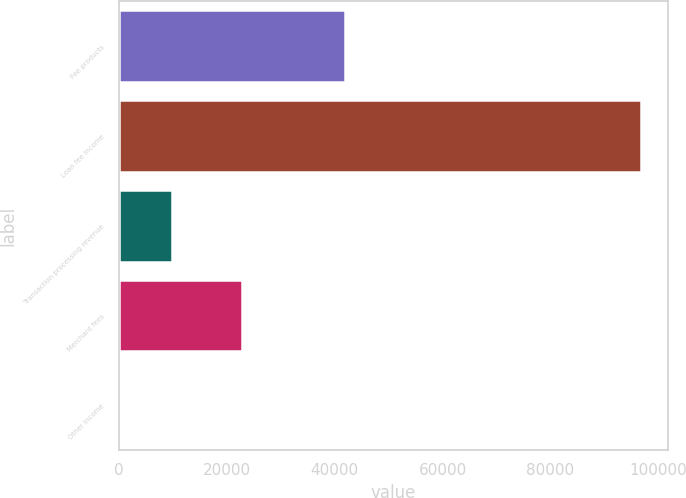Convert chart. <chart><loc_0><loc_0><loc_500><loc_500><bar_chart><fcel>Fee products<fcel>Loan fee income<fcel>Transaction processing revenue<fcel>Merchant fees<fcel>Other income<nl><fcel>41829<fcel>96874<fcel>9848.5<fcel>22779<fcel>179<nl></chart> 